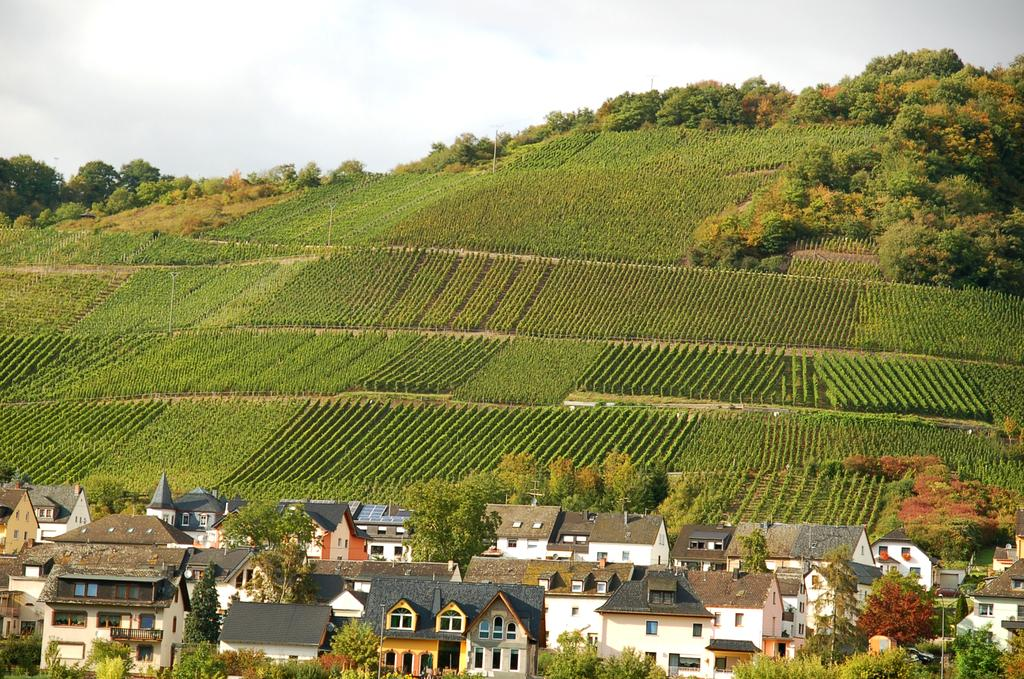What can be seen in the foreground of the image? There are trees and buildings in the foreground of the image. What is visible in the background of the image? There is greenery in the background of the image. What can be seen in the sky in the image? The sky is visible in the image, and clouds are present. What type of poison is being used to shock the plate in the image? There is no plate, poison, or shock present in the image. 